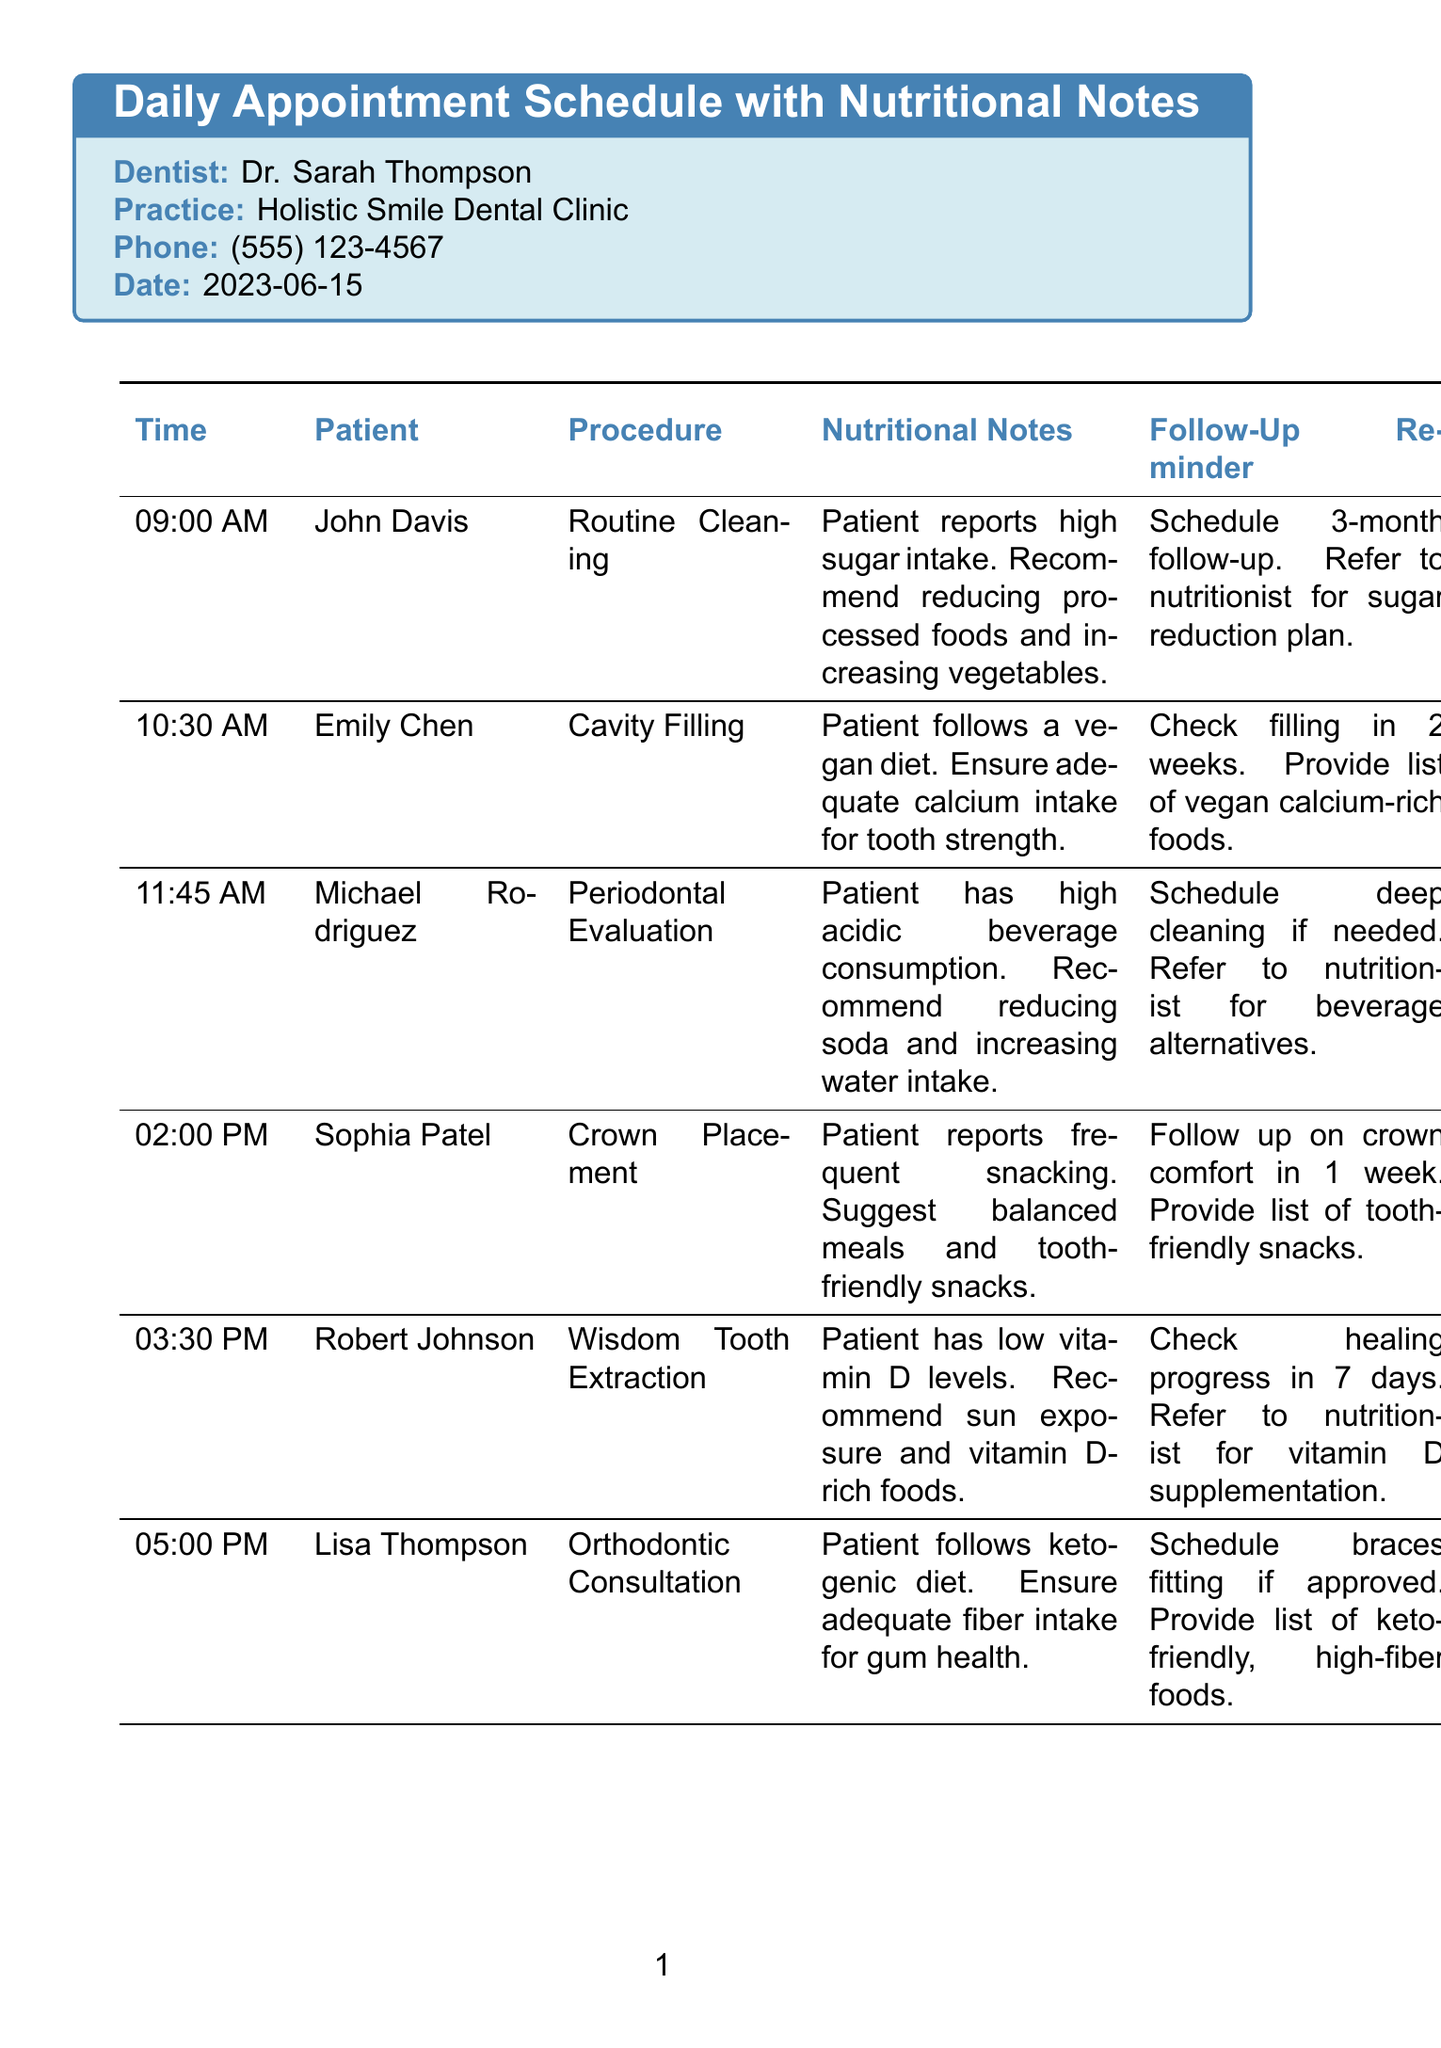what is the name of the dentist? The name of the dentist is provided in the document, listed under dentist information.
Answer: Dr. Sarah Thompson what time is John Davis's appointment? The appointment times are specified for each patient in the appointment schedule.
Answer: 09:00 AM what procedure does Emily Chen need? The procedures for each patient are detailed in the appointment section of the document.
Answer: Cavity Filling what nutritional recommendation is given to Michael Rodriguez? The nutritional notes for each patient outline specific recommendations made by the dentist.
Answer: Recommend reducing soda and increasing water intake how long until Robert Johnson's follow-up? The follow-up reminders include specific timing for each patient in the schedule.
Answer: 7 days what is Emma Greenfield's role? The document specifies the nutritionist's title in the referral section.
Answer: RDN which patient follows a ketogenic diet? The nutritional notes contain diet information for each patient.
Answer: Lisa Thompson what is one oral health tip mentioned in the document? The oral health tips provide general advice listed systematically in the document.
Answer: Drink water after meals to neutralize acid 